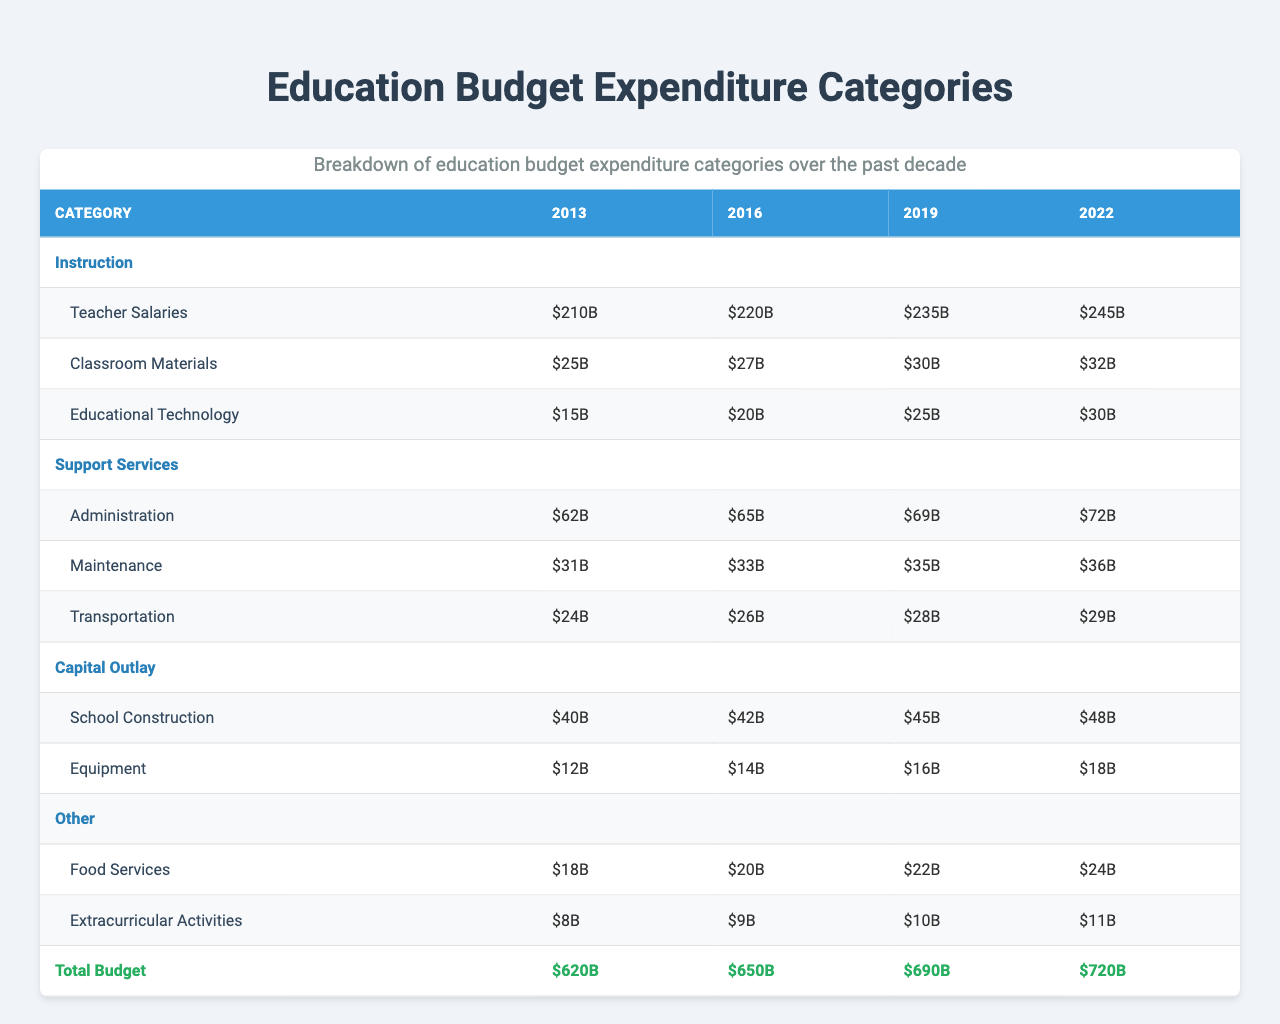What was the total education budget in 2013? The table shows that the total budget for the year 2013 is listed as $620 billion.
Answer: $620 billion How much was spent on teacher salaries in 2022? In the category of Instruction for the year 2022, the amount spent on teacher salaries is $245 billion.
Answer: $245 billion What was the increase in the total budget from 2013 to 2022? The total budget in 2013 was $620 billion and in 2022 it was $720 billion. The increase is $720 billion - $620 billion = $100 billion.
Answer: $100 billion How much was allocated for Educational Technology in 2019? The table reveals that in the year 2019, the expenditure for Educational Technology in the Instruction category was $25 billion.
Answer: $25 billion Which category saw the highest expenditure in the year 2016? Comparing the expenditure categories for 2016, the highest spending was in Instruction, specifically on Teacher Salaries which amounted to $220 billion.
Answer: Instruction Was there an increase in spending on Classroom Materials from 2013 to 2022? In 2013, $25 billion was spent on Classroom Materials, and by 2022, this figure rose to $32 billion. Therefore, there was an increase of $32 billion - $25 billion = $7 billion.
Answer: Yes What is the total amount spent on Support Services in 2019? In 2019, the expenditures in the Support Services category included: Administration ($69 billion), Maintenance ($35 billion), and Transportation ($28 billion). Summing these gives $69 billion + $35 billion + $28 billion = $132 billion.
Answer: $132 billion How much more was spent on School Construction in 2022 than in 2013? School Construction expenditure in 2013 was $40 billion, while in 2022, it increased to $48 billion. The difference is $48 billion - $40 billion = $8 billion.
Answer: $8 billion Did spending on Extracurricular Activities increase every year from 2013 to 2022? The table shows expenditures: $8 billion (2013), $9 billion (2016), $10 billion (2019), and $11 billion (2022). Since each amount is greater than the previous year's, spending increased every year.
Answer: Yes What percentage of the total budget was allocated to Instruction in the year 2016? In 2016, the total budget was $650 billion and Instruction expenditure was $220 billion. The percentage is calculated by ($220 billion / $650 billion) * 100 = 33.85%.
Answer: 33.85% 